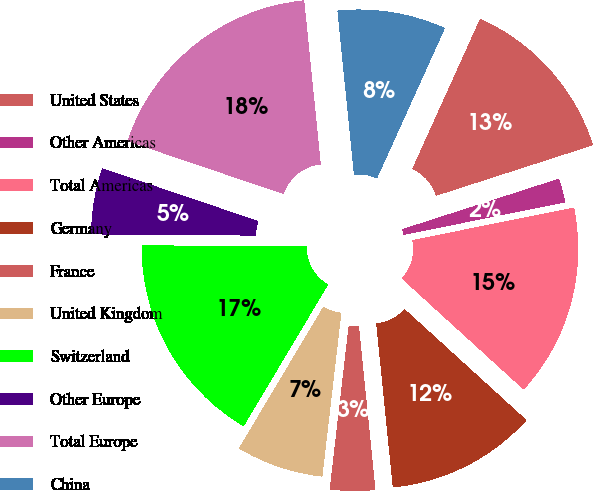<chart> <loc_0><loc_0><loc_500><loc_500><pie_chart><fcel>United States<fcel>Other Americas<fcel>Total Americas<fcel>Germany<fcel>France<fcel>United Kingdom<fcel>Switzerland<fcel>Other Europe<fcel>Total Europe<fcel>China<nl><fcel>13.28%<fcel>1.8%<fcel>14.92%<fcel>11.64%<fcel>3.44%<fcel>6.72%<fcel>16.56%<fcel>5.08%<fcel>18.2%<fcel>8.36%<nl></chart> 